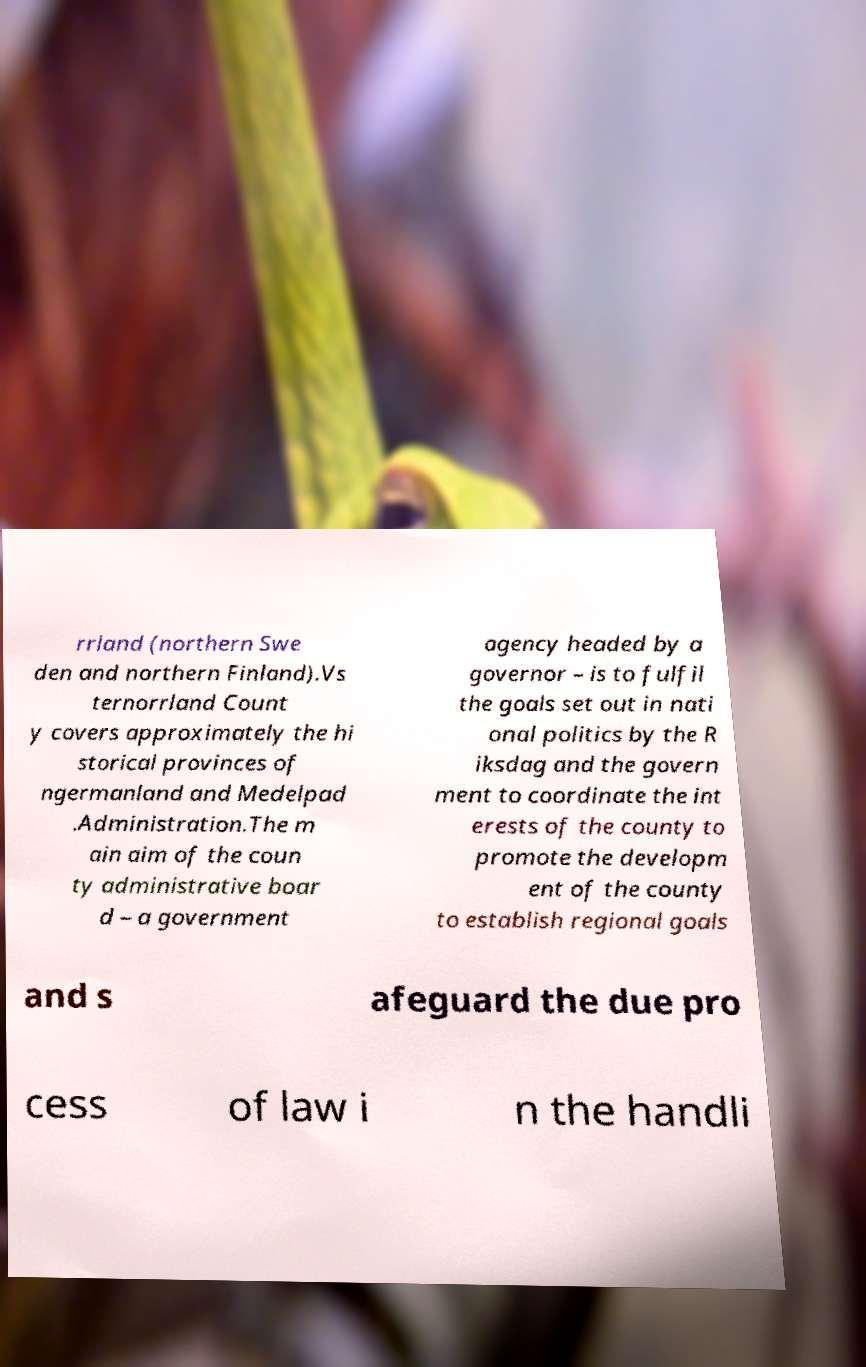Please read and relay the text visible in this image. What does it say? rrland (northern Swe den and northern Finland).Vs ternorrland Count y covers approximately the hi storical provinces of ngermanland and Medelpad .Administration.The m ain aim of the coun ty administrative boar d – a government agency headed by a governor – is to fulfil the goals set out in nati onal politics by the R iksdag and the govern ment to coordinate the int erests of the county to promote the developm ent of the county to establish regional goals and s afeguard the due pro cess of law i n the handli 